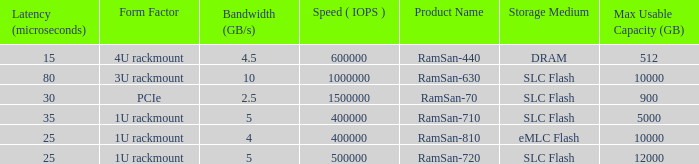What is the shape distortion for the range frequency of 10? 3U rackmount. 